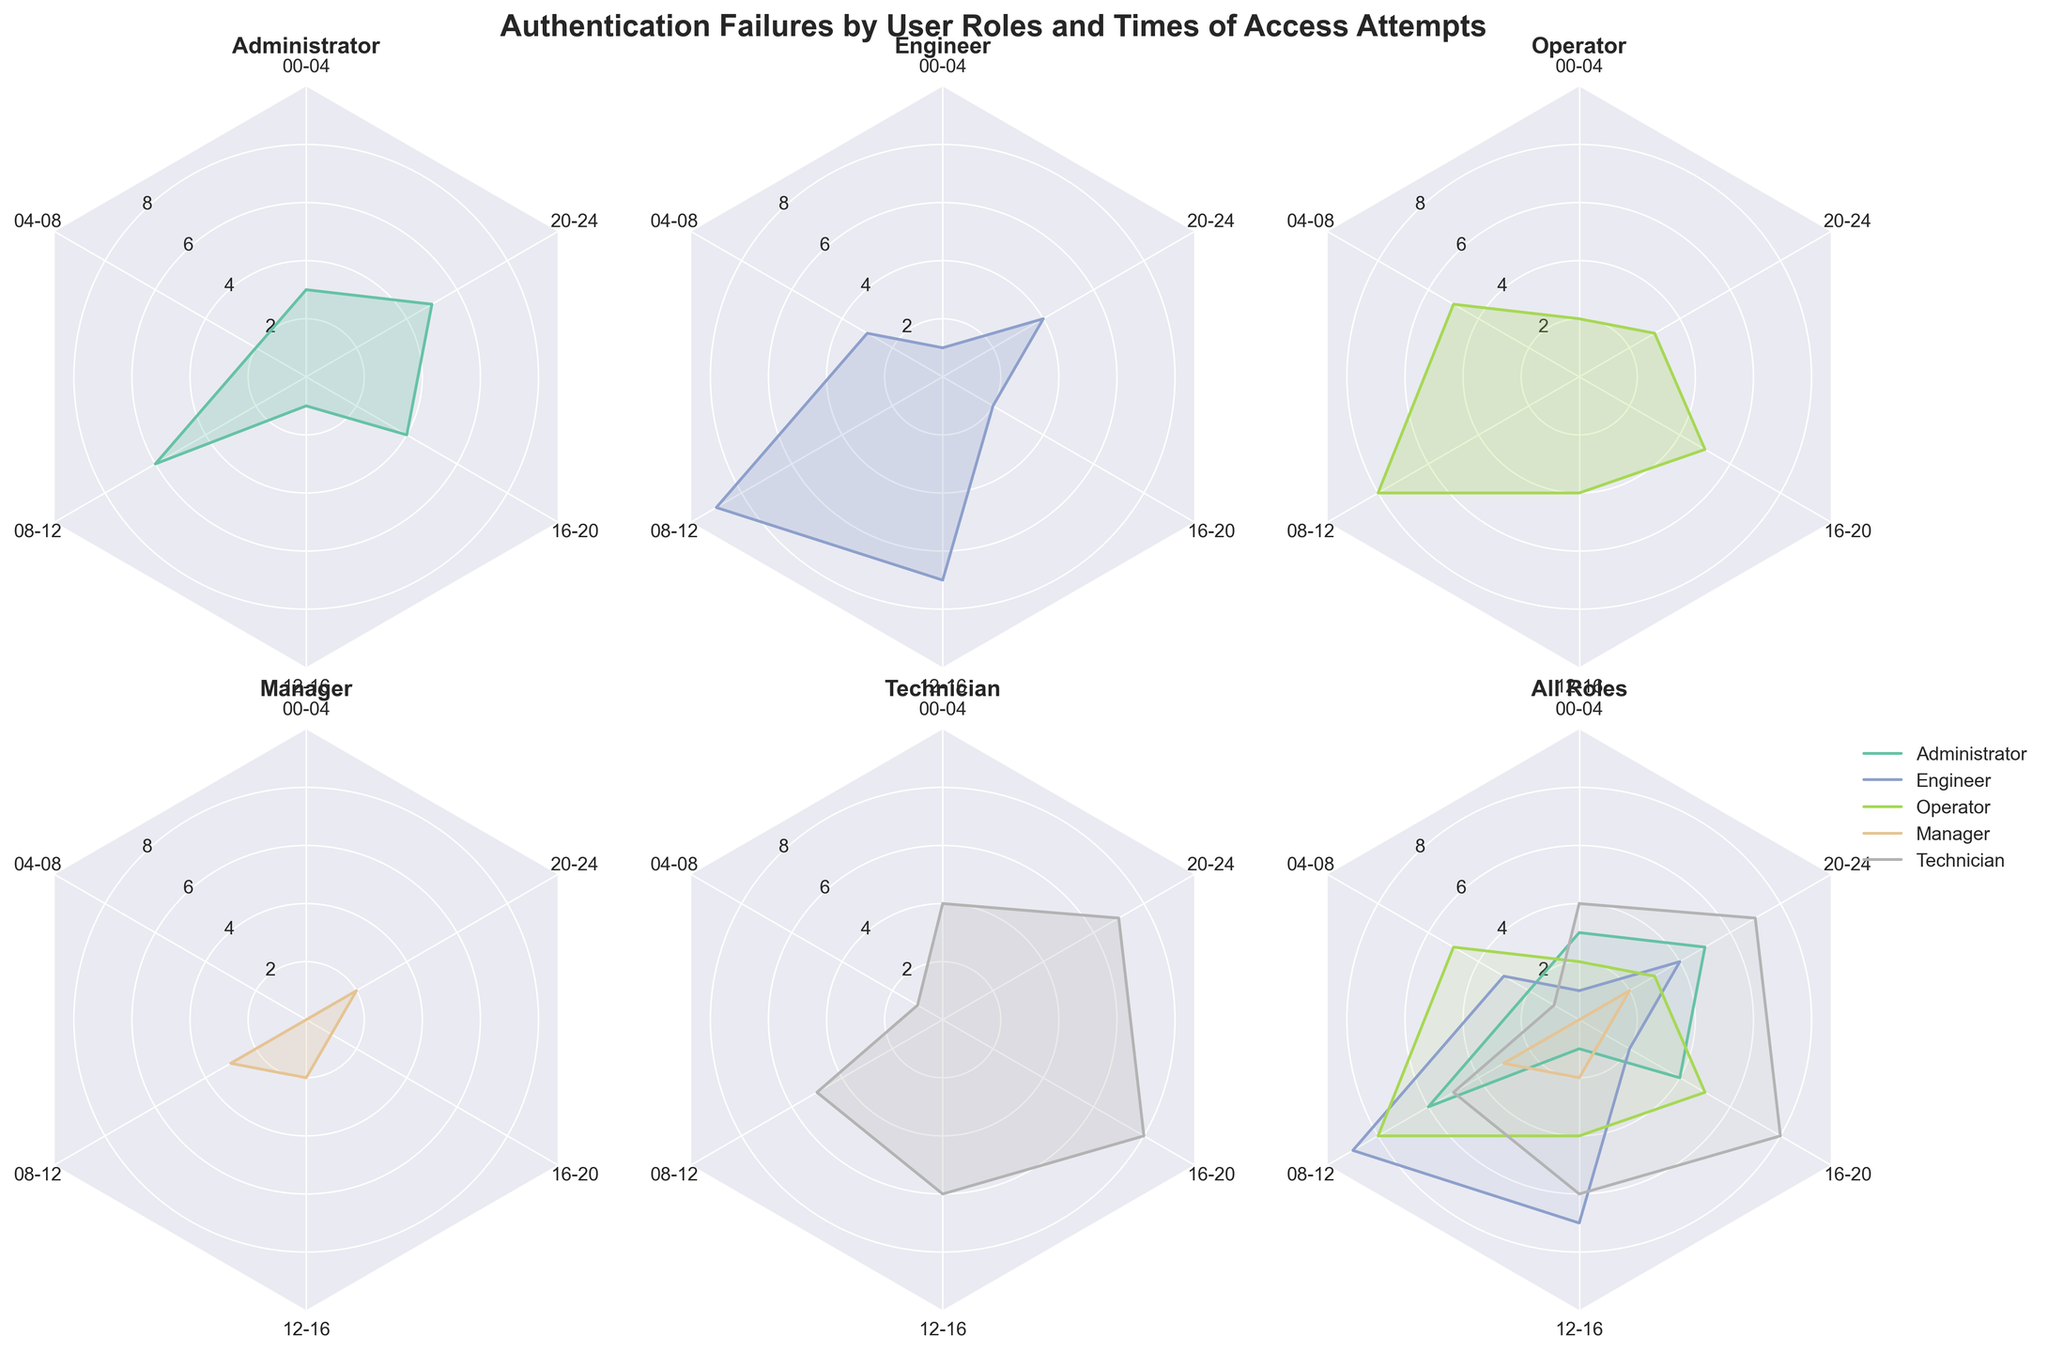How many authentication failures did Managers have between 16-20? Look at the subplot for the Manager role and observe the value on the corresponding axis for the 16-20 time period.
Answer: 1 Which role has the highest number of authentication failures between 08-12? Observe the subplots and compare the values on the 08-12 axis for each role to find the highest.
Answer: Engineer Between Administrators and Operators, which role had more authentication failures from 04-08? Compare the values on the 04-08 axis for both Administrator and Operator subplots.
Answer: Operator What is the average number of authentication failures for Technicians throughout the day? Add the values for the Technician plot (4+1+5+6+8+7) and divide by the number of time periods (6).
Answer: 5.17 How many roles had their peak number of authentication failures in the 20-24 time period? Check each role's subplot to see which ones have their highest value at 20-24.
Answer: 1 Which time period had the most authentication failures for the "Engineer" role? Observe the Engineer's radar plot and identify the highest point.
Answer: 08-12 Compare the total authentication failures between Engineers and Technicians throughout the day. Which one had more? Sum the values for both Engineer (1+3+9+7+2+4) and Technician (4+1+5+6+8+7) and compare.
Answer: Technician Which role has the most uniformly distributed authentication failures across all time periods? Observe each role's subplot and determine which one has the most even distribution of values across all time periods.
Answer: Manager How many times did the "Operator" role experience authentication failures greater than 5? Check the Operator's values for each time period and count how many are greater than 5.
Answer: 1 